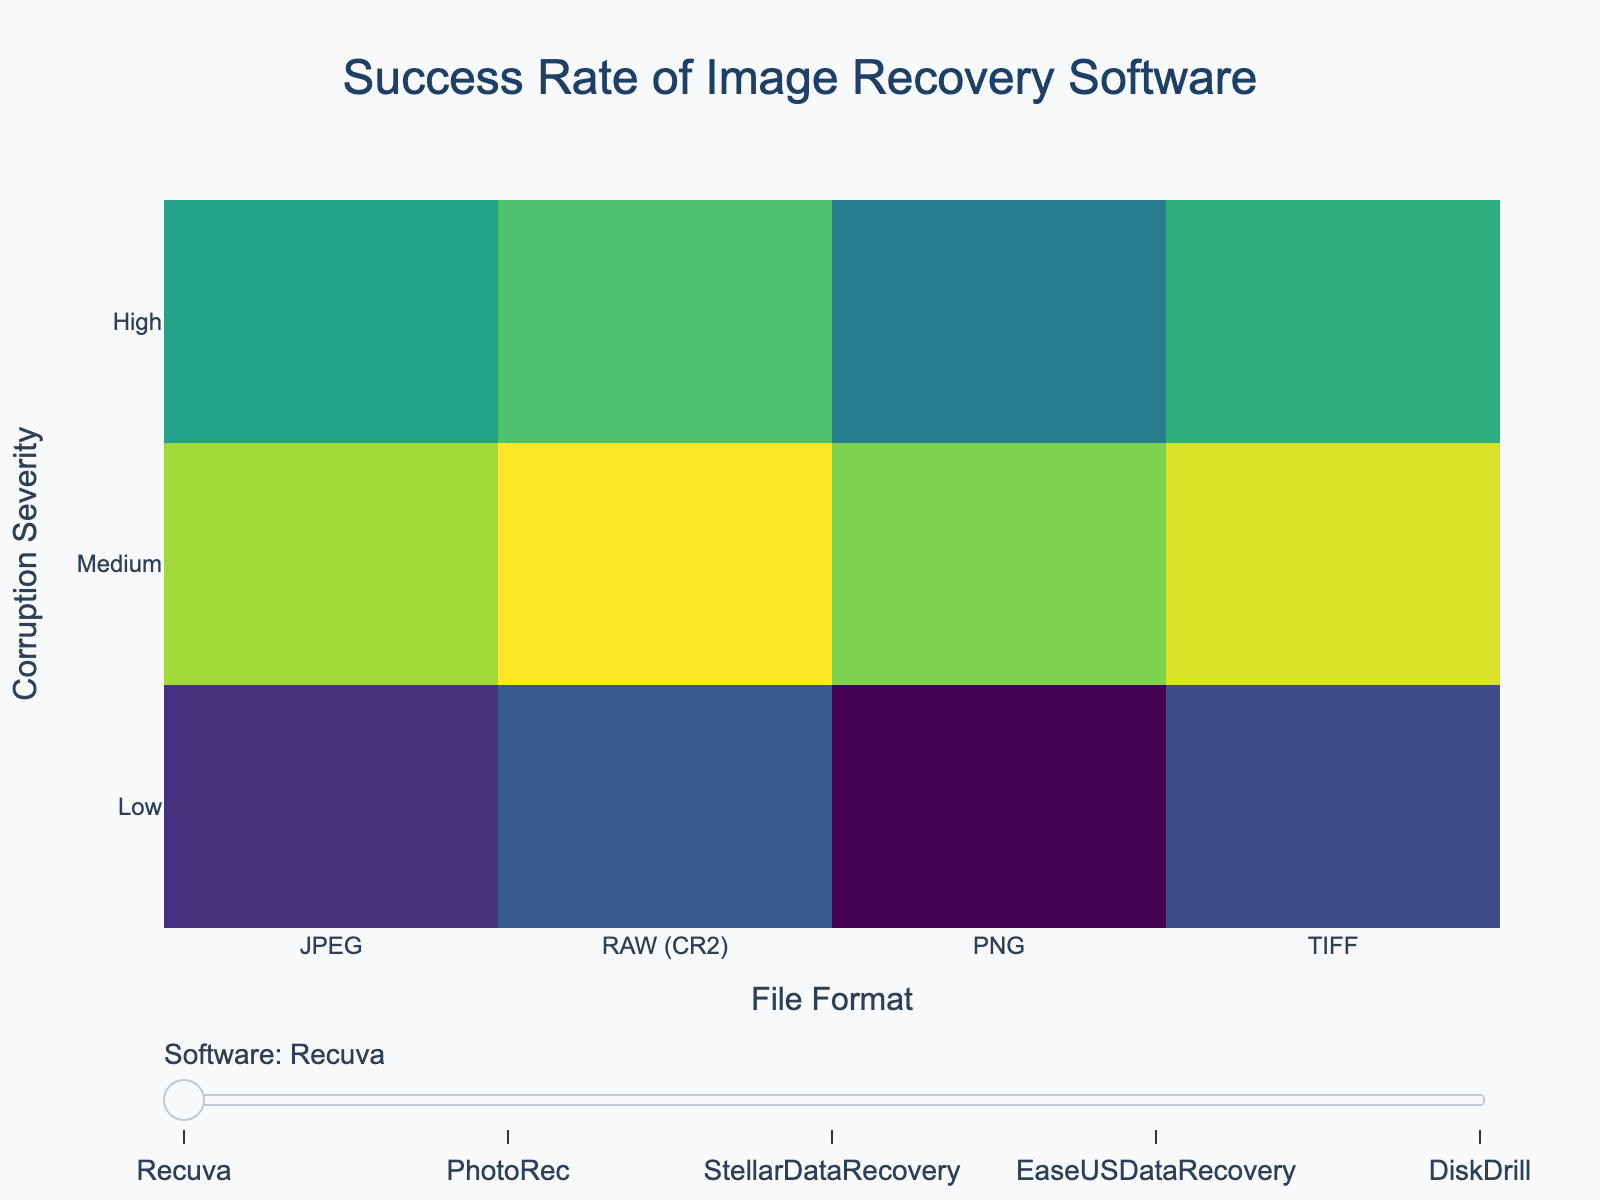What is the file format with the highest recovery success rate at low corruption severity for Recuva? To find this, look at the heatmap for Recuva and identify which file format has the highest value in the 'Low' corruption severity row.
Answer: PNG How does the success rate for recovering JPEG files at high corruption severity compare between Recuva and EaseUS Data Recovery? Check Recuva's heatmap for the value at JPEG and High severity, then do the same for EaseUS Data Recovery's heatmap and compare the two values.
Answer: Recuva: 65, EaseUS Data Recovery: 72 What is the average success rate of Stellar Data Recovery for all corruption severities of RAW (CR2) files? Find the values for Stellar Data Recovery across all corruption severities (Low, Medium, High) for RAW (CR2) files, then calculate their average: (90 + 85 + 70) / 3
Answer: 81.67 Which software has the lowest success rate for TIFF files at medium corruption severity, and what is that rate? Identify the values for all software at TIFF and Medium severity on their respective heatmaps, and find the minimum rate.
Answer: Disk Drill, 79 What's the difference in success rate between PhotoRec and Stellar Data Recovery for PNG files at low corruption severity? Find the values for PhotoRec and Stellar Data Recovery at PNG and Low severity on their respective heatmaps, then calculate the difference: 97 - 96
Answer: 1 Among JPEG, RAW (CR2), PNG, and TIFF, which format has the largest variation in recovery success rates across all severities for PhotoRec? For PhotoRec, find the range (max value - min value) of the success rates for each file format across all severities (Low, Medium, High). Compare these ranges and find the maximum.
Answer: RAW (CR2) What's the median success rate for Disk Drill when recovering PNG files across all corruption severities? Extract Disk Drill's success rates for PNG files at all severities (Low, Medium, High) and calculate the median value: (93 + 83 + 71), then find the middle number in the ordered set.
Answer: 83 If you only care about high severity corruption, which software would you choose based on the highest overall recovery success rates across all file formats? Summarize and compare the success rates for each software at High severity across all file formats. Identify the software with the highest cumulative success rates.
Answer: Stellar Data Recovery 